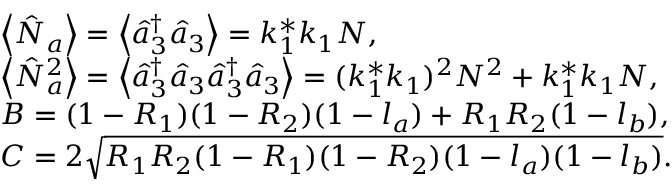Convert formula to latex. <formula><loc_0><loc_0><loc_500><loc_500>\begin{array} { r l r } & { \left \langle \hat { N } _ { a } \right \rangle = \left \langle \hat { a } _ { 3 } ^ { \dag } \hat { a } _ { 3 } \right \rangle = k _ { 1 } ^ { \ast } k _ { 1 } N , } & \\ & { \left \langle \hat { N } _ { a } ^ { 2 } \right \rangle = \left \langle \hat { a } _ { 3 } ^ { \dag } \hat { a } _ { 3 } \hat { a } _ { 3 } ^ { \dag } \hat { a } _ { 3 } \right \rangle = ( k _ { 1 } ^ { \ast } k _ { 1 } ) ^ { 2 } N ^ { 2 } + k _ { 1 } ^ { \ast } k _ { 1 } N , } & \\ & { B = ( 1 - R _ { 1 } ) ( 1 - R _ { 2 } ) ( 1 - l _ { a } ) + R _ { 1 } R _ { 2 } ( 1 - l _ { b } ) , } & \\ & { C = 2 \sqrt { R _ { 1 } R _ { 2 } ( 1 - R _ { 1 } ) ( 1 - R _ { 2 } ) ( 1 - l _ { a } ) ( 1 - l _ { b } ) } . } & \end{array}</formula> 